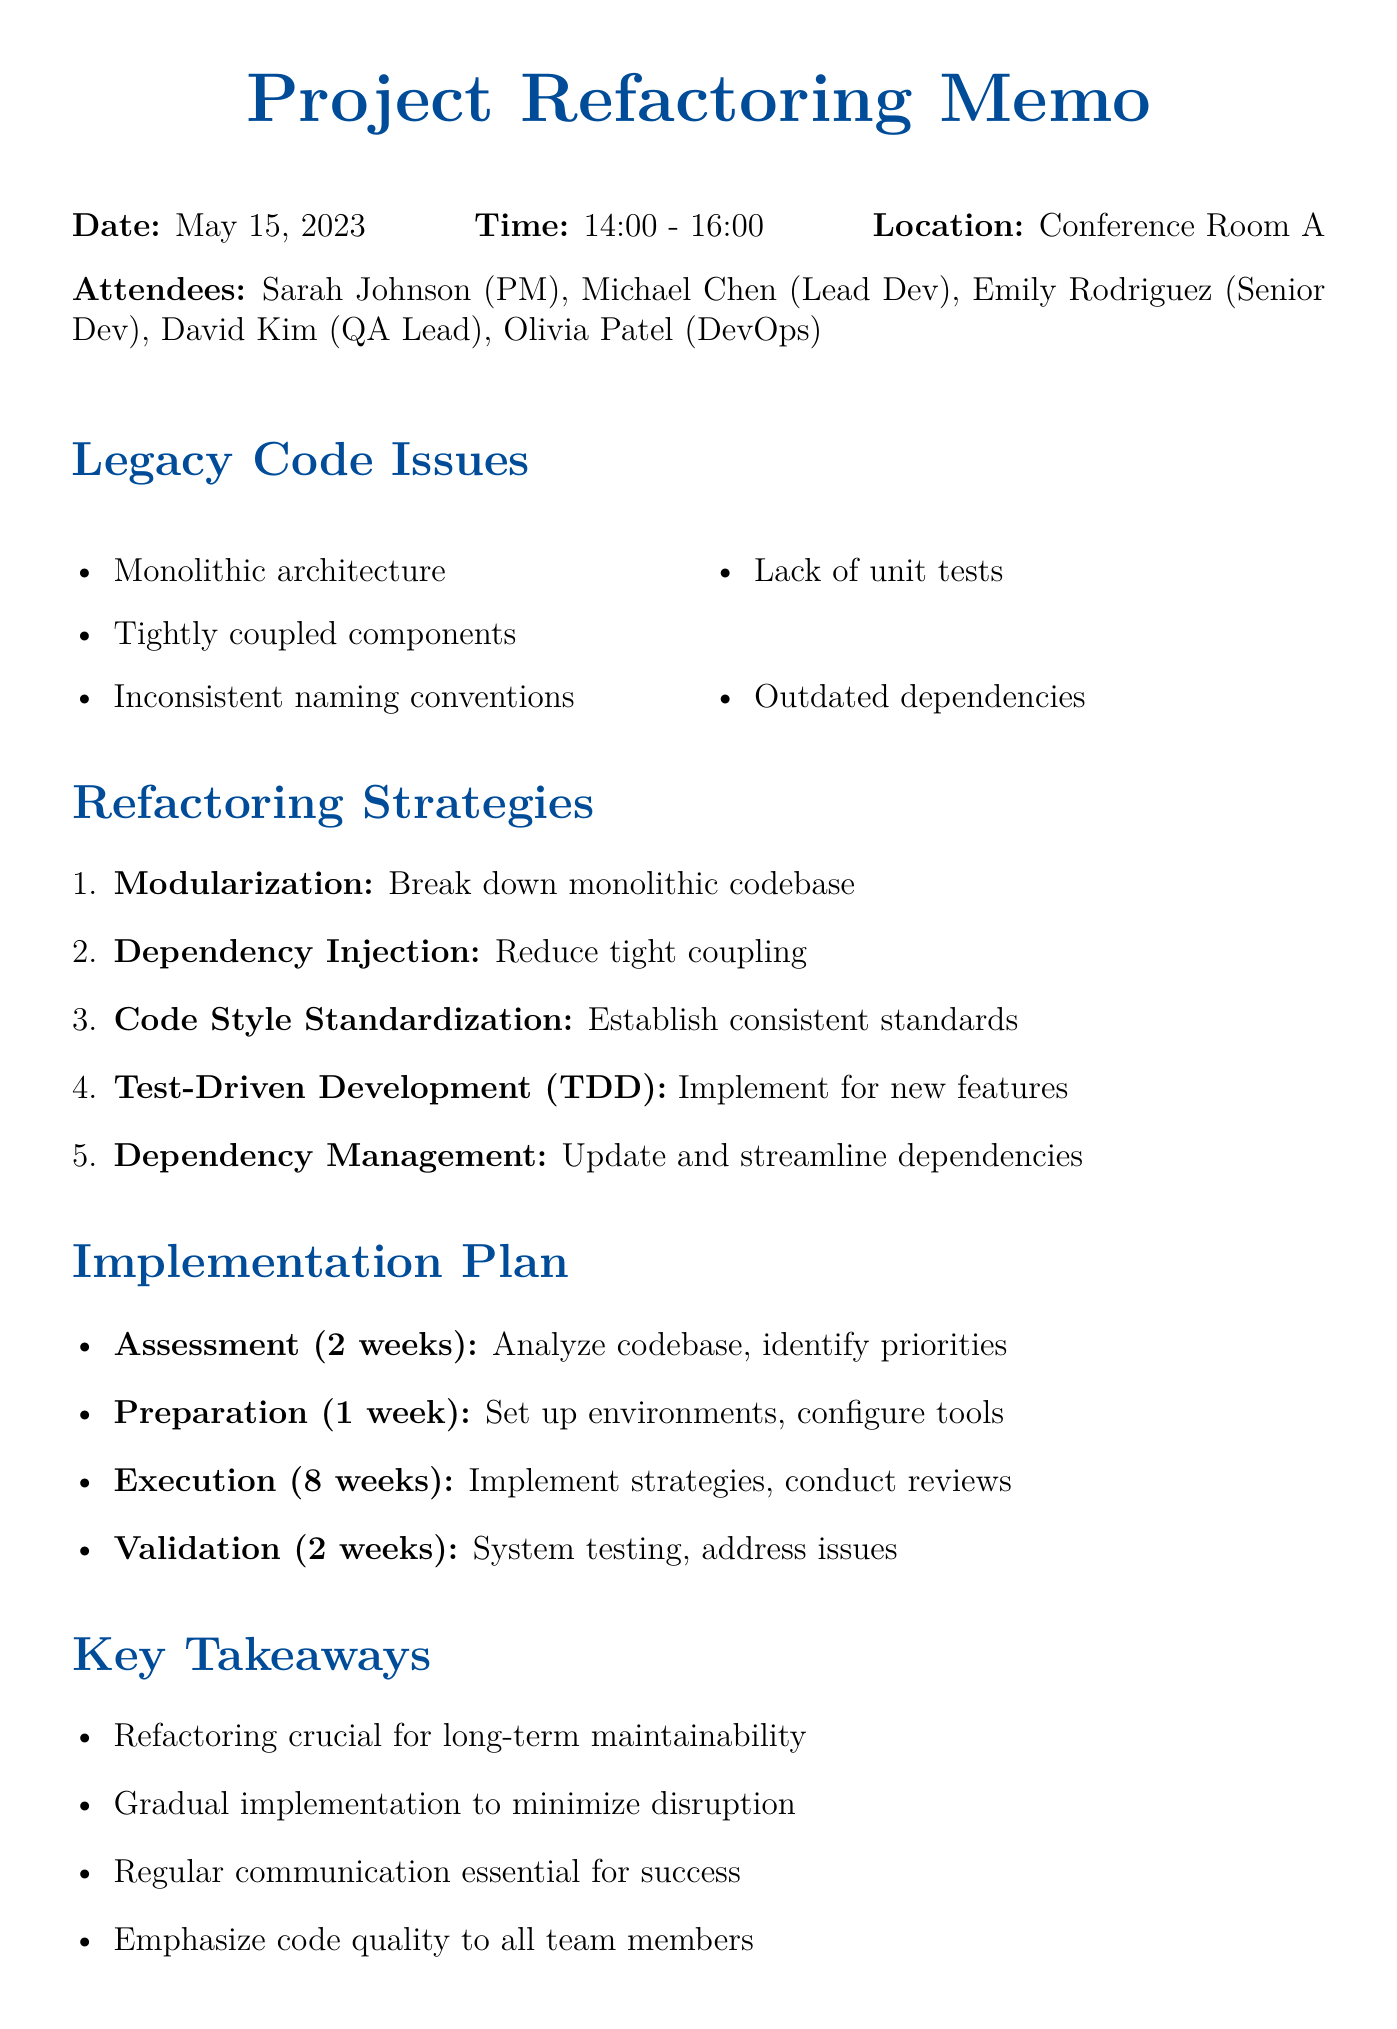What is the date of the meeting? The date of the meeting is specified in the document.
Answer: May 15, 2023 Who is the Lead Developer attending the meeting? The document lists the attendees and their roles.
Answer: Michael Chen What is one of the key takeaways from the meeting? The document highlights several key takeaways from the meeting.
Answer: Refactoring crucial for long-term maintainability How long is the Assessment phase of the implementation plan? The duration of each phase is stated in the implementation plan section.
Answer: 2 weeks What is one of the refactoring strategies discussed in the meeting? The document enumerates various refactoring strategies.
Answer: Modularization How many attendees were present at the meeting? The number of attendees is provided in the meeting details section.
Answer: 5 What tool is mentioned for code quality analysis? The document lists tools that will be used in the refactoring process.
Answer: SonarQube What phase follows the Preparation phase in the implementation plan? The implementation plan outlines the sequence of phases.
Answer: Execution 